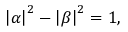Convert formula to latex. <formula><loc_0><loc_0><loc_500><loc_500>\left | \alpha \right | ^ { 2 } - \left | \beta \right | ^ { 2 } = 1 ,</formula> 